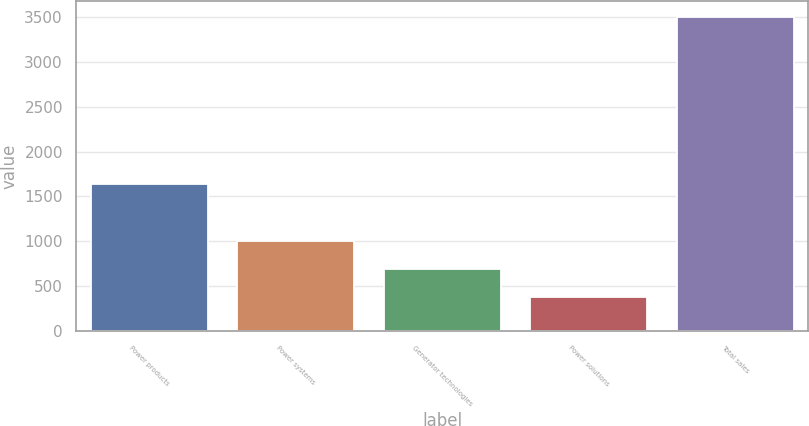<chart> <loc_0><loc_0><loc_500><loc_500><bar_chart><fcel>Power products<fcel>Power systems<fcel>Generator technologies<fcel>Power solutions<fcel>Total sales<nl><fcel>1636<fcel>998.8<fcel>686.4<fcel>374<fcel>3498<nl></chart> 